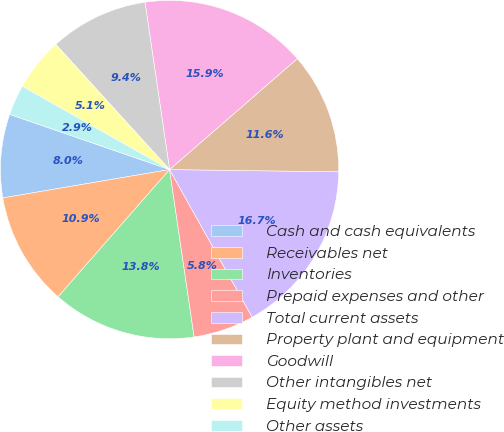Convert chart to OTSL. <chart><loc_0><loc_0><loc_500><loc_500><pie_chart><fcel>Cash and cash equivalents<fcel>Receivables net<fcel>Inventories<fcel>Prepaid expenses and other<fcel>Total current assets<fcel>Property plant and equipment<fcel>Goodwill<fcel>Other intangibles net<fcel>Equity method investments<fcel>Other assets<nl><fcel>7.97%<fcel>10.87%<fcel>13.77%<fcel>5.8%<fcel>16.67%<fcel>11.59%<fcel>15.94%<fcel>9.42%<fcel>5.07%<fcel>2.9%<nl></chart> 